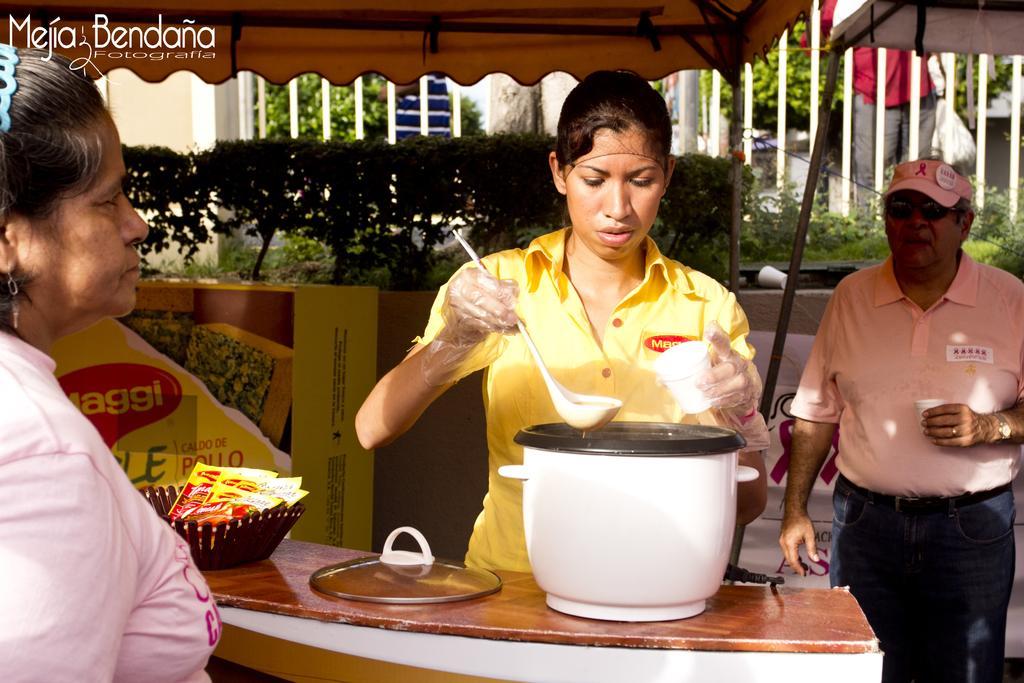Describe this image in one or two sentences. In this picture there is a lady in the center of the image, by holding a spoon and a cup in her hands, there is desk in front of her on which there are wrappers and an utensil, there is a lady on the left side of the image and there is a man on the right side of the image, there are trees and a building in the background area of the image. 